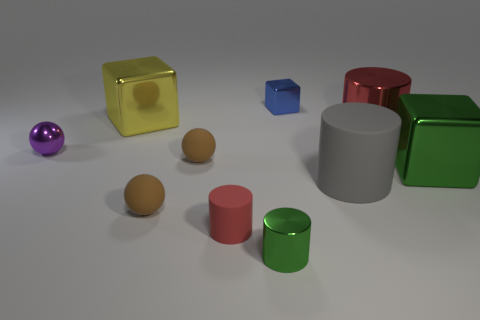Subtract all cylinders. How many objects are left? 6 Subtract all small green cylinders. Subtract all small green cylinders. How many objects are left? 8 Add 9 tiny shiny spheres. How many tiny shiny spheres are left? 10 Add 8 big blue metal cubes. How many big blue metal cubes exist? 8 Subtract 0 gray balls. How many objects are left? 10 